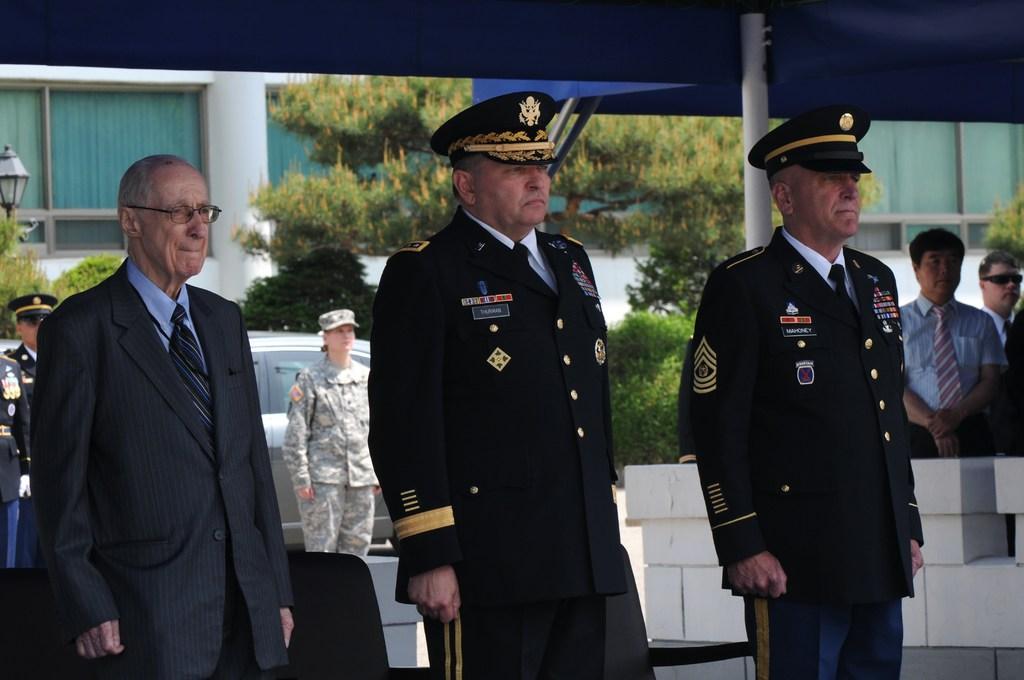In one or two sentences, can you explain what this image depicts? In this image we can see two men in uniform. We can see the other man on the left wearing the suit. In the background we can see few people. Image also consists of building and also trees. We can also see the car, light pole and also the tent. 